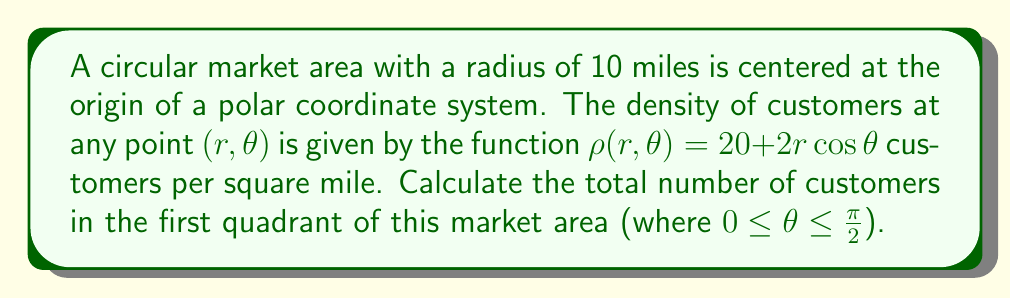Can you solve this math problem? To solve this problem, we need to integrate the density function over the first quadrant of the circular market area. We'll use polar coordinates for this integration.

1) The area element in polar coordinates is $dA = r \, dr \, d\theta$.

2) The limits of integration are:
   $0 \leq r \leq 10$ (radius from center to edge of market area)
   $0 \leq \theta \leq \frac{\pi}{2}$ (first quadrant)

3) Set up the double integral:

   $$N = \int_{0}^{\frac{\pi}{2}} \int_{0}^{10} \rho(r,\theta) \, r \, dr \, d\theta$$

4) Substitute the density function:

   $$N = \int_{0}^{\frac{\pi}{2}} \int_{0}^{10} (20 + 2r\cos\theta) \, r \, dr \, d\theta$$

5) Distribute $r$:

   $$N = \int_{0}^{\frac{\pi}{2}} \int_{0}^{10} (20r + 2r^2\cos\theta) \, dr \, d\theta$$

6) Integrate with respect to $r$:

   $$N = \int_{0}^{\frac{\pi}{2}} \left[\frac{20r^2}{2} + \frac{2r^3\cos\theta}{3}\right]_{0}^{10} \, d\theta$$

7) Evaluate the inner integral:

   $$N = \int_{0}^{\frac{\pi}{2}} \left(1000 + \frac{2000\cos\theta}{3}\right) \, d\theta$$

8) Integrate with respect to $\theta$:

   $$N = \left[1000\theta + \frac{2000\sin\theta}{3}\right]_{0}^{\frac{\pi}{2}}$$

9) Evaluate the outer integral:

   $$N = \left(1000 \cdot \frac{\pi}{2} + \frac{2000}{3} \cdot 1\right) - \left(1000 \cdot 0 + \frac{2000}{3} \cdot 0\right)$$

10) Simplify:

    $$N = 500\pi + \frac{2000}{3} \approx 2237.72$$
Answer: The total number of customers in the first quadrant of the market area is approximately 2,238 customers. 